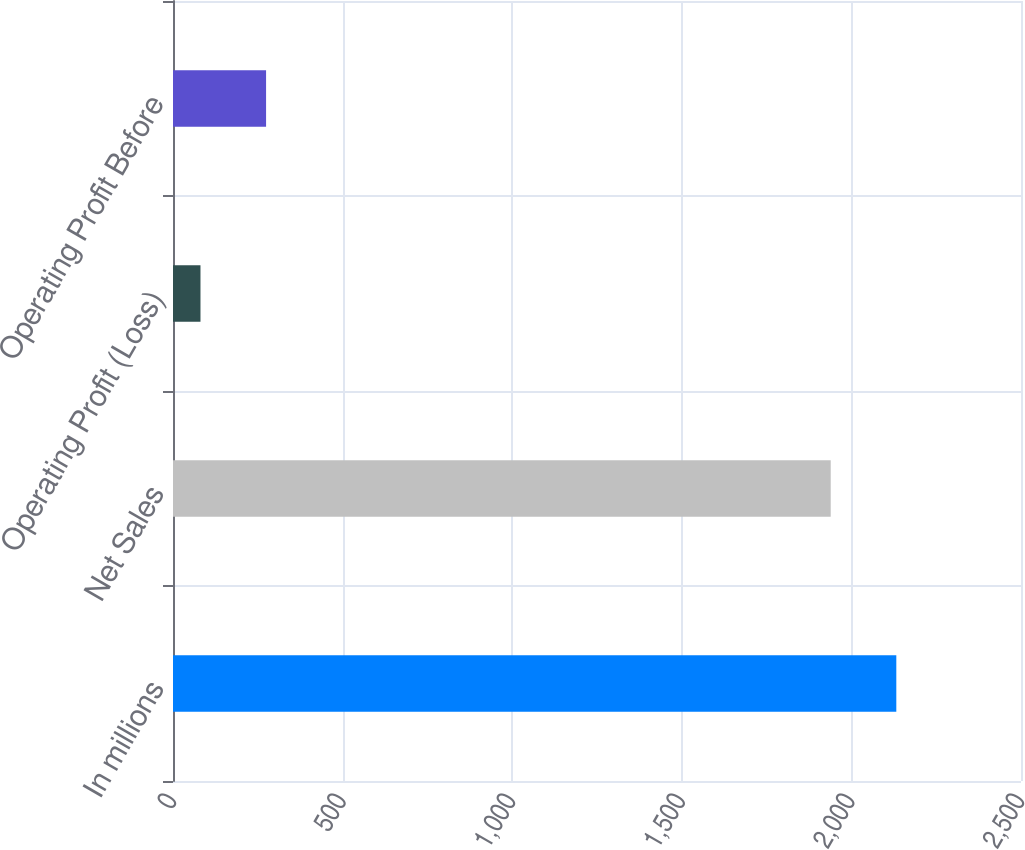<chart> <loc_0><loc_0><loc_500><loc_500><bar_chart><fcel>In millions<fcel>Net Sales<fcel>Operating Profit (Loss)<fcel>Operating Profit Before<nl><fcel>2132.4<fcel>1939<fcel>81<fcel>274.4<nl></chart> 